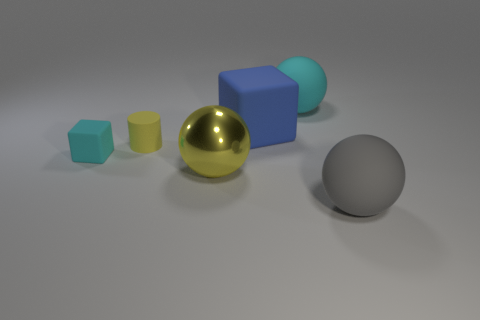Add 1 brown spheres. How many objects exist? 7 Subtract all rubber balls. How many balls are left? 1 Subtract all yellow balls. How many balls are left? 2 Subtract all cylinders. How many objects are left? 5 Subtract all tiny cylinders. Subtract all yellow metal balls. How many objects are left? 4 Add 1 small cylinders. How many small cylinders are left? 2 Add 1 brown balls. How many brown balls exist? 1 Subtract 0 red cylinders. How many objects are left? 6 Subtract 2 blocks. How many blocks are left? 0 Subtract all purple balls. Subtract all brown cubes. How many balls are left? 3 